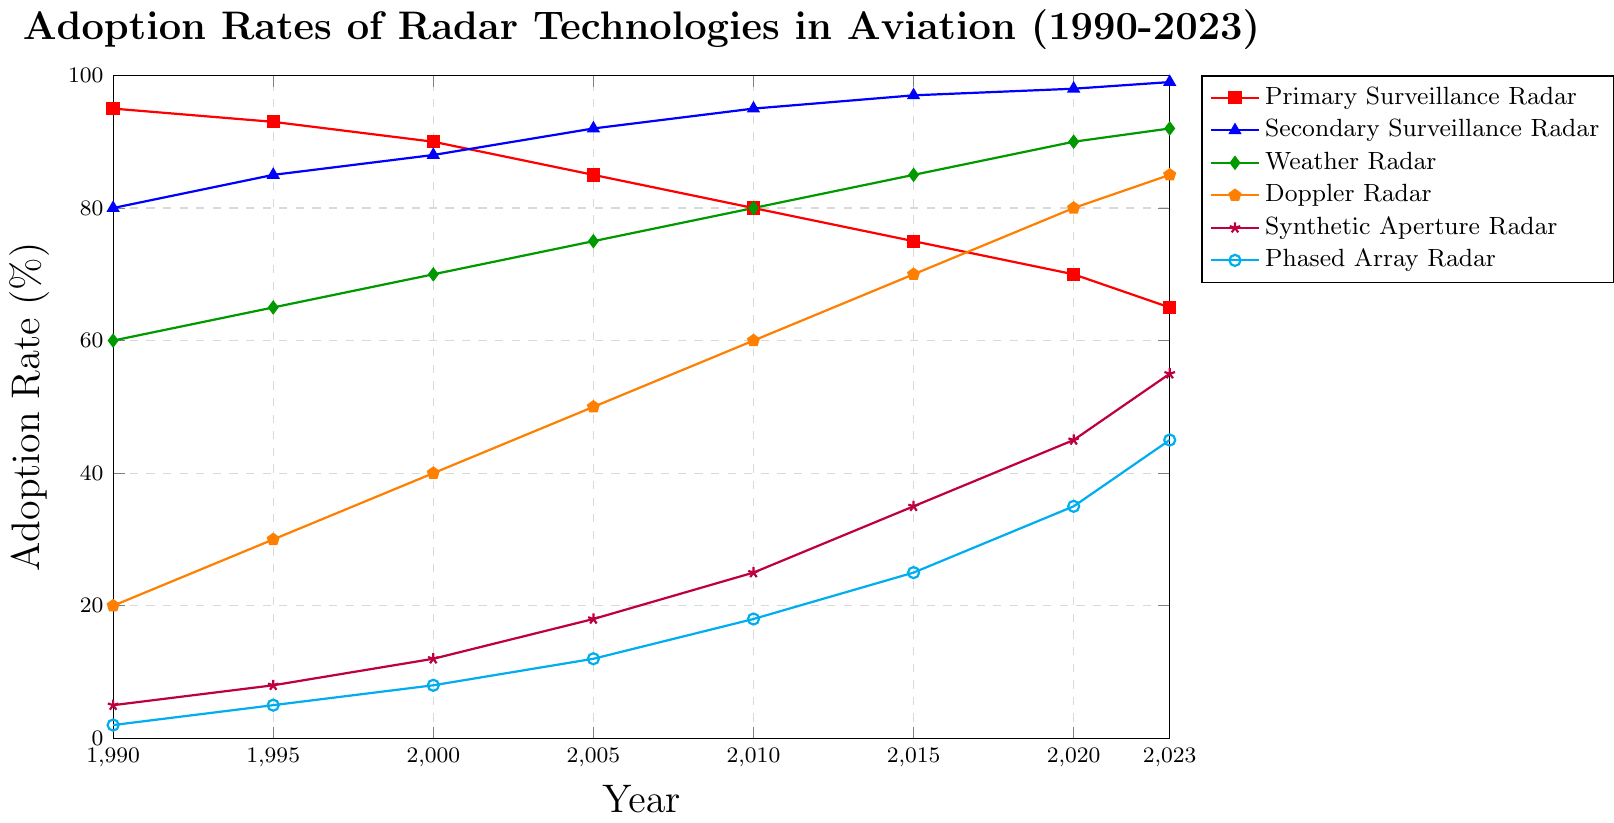What's the trend for Primary Surveillance Radar adoption from 1990 to 2023? The Primary Surveillance Radar adoption rate shows a consistent decline from 95% in 1990 to 65% in 2023, indicating a downward trend over the period.
Answer: Downward trend Which radar technology had the highest adoption rate in 2023? In 2023, the Secondary Surveillance Radar had the highest adoption rate at 99%, surpassing all other radar technologies.
Answer: Secondary Surveillance Radar How much did the adoption rate of Doppler Radar increase from 1990 to 2005? The Doppler Radar adoption rate increased from 20% in 1990 to 50% in 2005. The increase is calculated as 50% - 20% = 30%.
Answer: 30% Which radar technology saw the most significant growth between 2000 and 2023? To determine the most significant growth, we compare the differences in adoption rates between 2000 and 2023 for each technology. The Synthetic Aperture Radar grew from 12% to 55%, which is an increase of 43%. This is the largest growth among all radar technologies in that period.
Answer: Synthetic Aperture Radar Was the adoption rate of Weather Radar in 2023 higher than that of Phased Array Radar in 2015? The adoption rate of Weather Radar in 2023 was 92%, while the Phased Array Radar had a 25% adoption rate in 2015. Thus, the adoption rate of Weather Radar in 2023 was higher.
Answer: Yes What was the average adoption rate of Secondary Surveillance Radar from 1990 to 2023? We sum up the adoption rates of Secondary Surveillance Radar for all years: 80 + 85 + 88 + 92 + 95 + 97 + 98 + 99 = 734. Then, we divide by the number of years (8): 734 / 8 = 91.75%.
Answer: 91.75% Compare the adoption rates of Weather Radar and Doppler Radar in 2010. Which was higher and by how much? In 2010, the adoption rate for Weather Radar was 80% while for Doppler Radar it was 60%. Weather Radar had a higher adoption rate by 80% - 60% = 20%.
Answer: Weather Radar by 20% In which year did Secondary Surveillance Radar surpass Primary Surveillance Radar in adoption rate, and by how much? In 2000, the adoption rate of Secondary Surveillance Radar was 88%, higher than the 90% for Primary Surveillance Radar, surpassing it by 3 percentage points. This trend continues in subsequent years, but 2000 is the first instance.
Answer: 2000, by 3% What was the combined adoption rate of Phased Array Radar and Synthetic Aperture Radar in 2023? The adoption rate of Phased Array Radar in 2023 was 45%, and for Synthetic Aperture Radar it was 55%. The combined adoption rate is 45% + 55% = 100%.
Answer: 100% Between 1995 and 2023, which radar technology experienced the smallest increase in adoption rate? To find the smallest increase, we calculate the difference between 2023 and 1995 for each technology. The smallest increase was seen in Primary Surveillance Radar, dropping from 93% to 65%, resulting in a decrease of -28%, indicating it actually decreased rather than increased.
Answer: Primary Surveillance Radar 